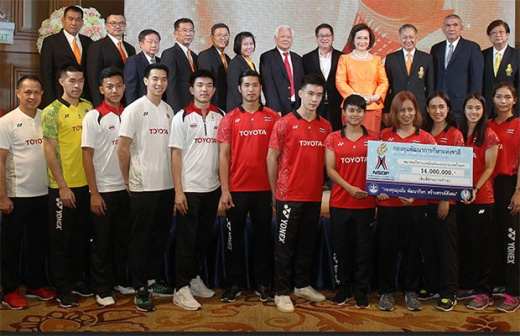Can you describe the main features of this image for me? The image captures a group scene in an opulent room, where several individuals are gathered around a large ceremonial check for 16,000,000 Thai Baht. The two people holding the check stand out, with one of them wearing a vivid red shirt, drawing immediate attention. In the front row, people are dressed in sporty uniforms branded with the Toyota logo, possibly indicating a sponsorship or partnership. Behind them, individuals dressed in formal attire stand on a slightly elevated stage, creating a sense of hierarchy and occasion. A curtain and a chandelier in the background add to the room's luxurious atmosphere. The image suggests a celebratory event involving a significant monetary award or donation. 